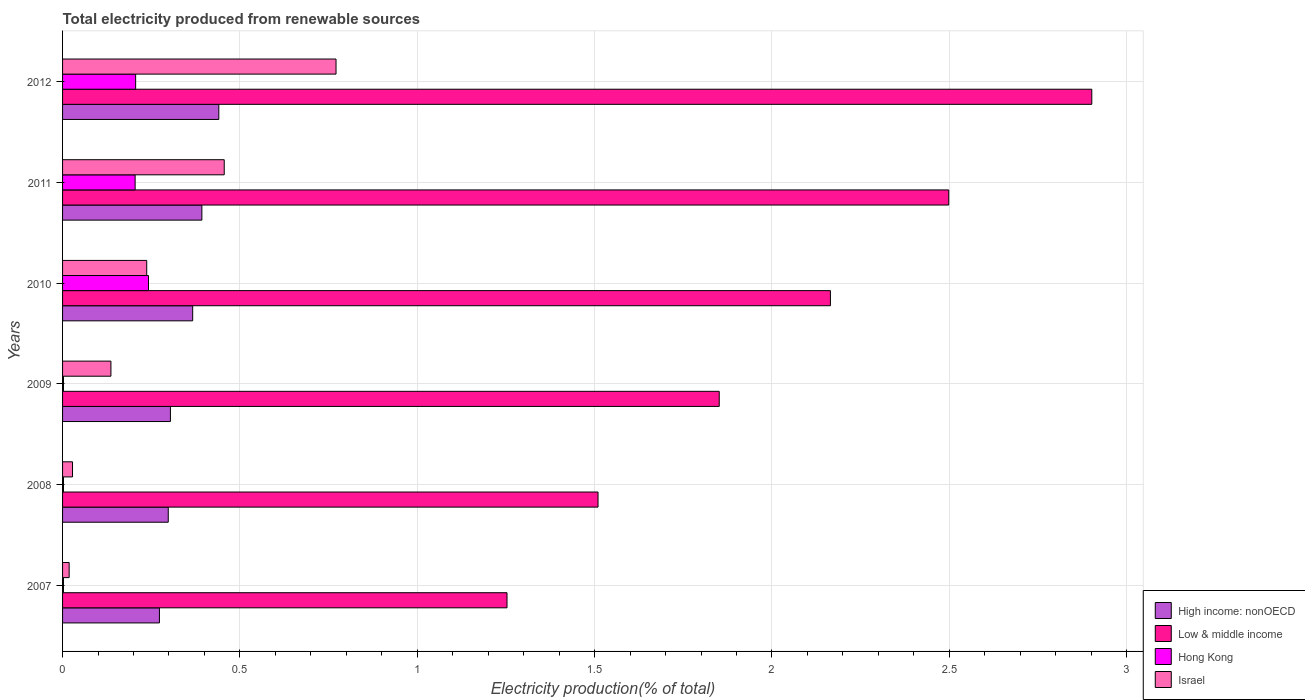Are the number of bars on each tick of the Y-axis equal?
Provide a short and direct response. Yes. What is the label of the 5th group of bars from the top?
Offer a very short reply. 2008. In how many cases, is the number of bars for a given year not equal to the number of legend labels?
Provide a succinct answer. 0. What is the total electricity produced in High income: nonOECD in 2012?
Offer a terse response. 0.44. Across all years, what is the maximum total electricity produced in Hong Kong?
Make the answer very short. 0.24. Across all years, what is the minimum total electricity produced in Low & middle income?
Your response must be concise. 1.25. In which year was the total electricity produced in Israel minimum?
Ensure brevity in your answer.  2007. What is the total total electricity produced in Israel in the graph?
Provide a short and direct response. 1.65. What is the difference between the total electricity produced in Israel in 2008 and that in 2011?
Offer a terse response. -0.43. What is the difference between the total electricity produced in Israel in 2007 and the total electricity produced in Low & middle income in 2012?
Your answer should be very brief. -2.88. What is the average total electricity produced in High income: nonOECD per year?
Offer a very short reply. 0.35. In the year 2007, what is the difference between the total electricity produced in Low & middle income and total electricity produced in Israel?
Give a very brief answer. 1.23. What is the ratio of the total electricity produced in High income: nonOECD in 2010 to that in 2012?
Provide a succinct answer. 0.83. Is the difference between the total electricity produced in Low & middle income in 2008 and 2009 greater than the difference between the total electricity produced in Israel in 2008 and 2009?
Offer a terse response. No. What is the difference between the highest and the second highest total electricity produced in Low & middle income?
Offer a terse response. 0.4. What is the difference between the highest and the lowest total electricity produced in Low & middle income?
Provide a short and direct response. 1.65. In how many years, is the total electricity produced in High income: nonOECD greater than the average total electricity produced in High income: nonOECD taken over all years?
Offer a very short reply. 3. Is the sum of the total electricity produced in Hong Kong in 2009 and 2012 greater than the maximum total electricity produced in Israel across all years?
Provide a short and direct response. No. Is it the case that in every year, the sum of the total electricity produced in Israel and total electricity produced in Hong Kong is greater than the sum of total electricity produced in High income: nonOECD and total electricity produced in Low & middle income?
Give a very brief answer. No. What does the 1st bar from the top in 2012 represents?
Your response must be concise. Israel. What does the 3rd bar from the bottom in 2010 represents?
Keep it short and to the point. Hong Kong. Is it the case that in every year, the sum of the total electricity produced in Hong Kong and total electricity produced in Israel is greater than the total electricity produced in High income: nonOECD?
Provide a short and direct response. No. How many bars are there?
Ensure brevity in your answer.  24. How many years are there in the graph?
Offer a terse response. 6. Are the values on the major ticks of X-axis written in scientific E-notation?
Your response must be concise. No. Does the graph contain any zero values?
Provide a short and direct response. No. Does the graph contain grids?
Keep it short and to the point. Yes. Where does the legend appear in the graph?
Offer a very short reply. Bottom right. How are the legend labels stacked?
Your response must be concise. Vertical. What is the title of the graph?
Offer a very short reply. Total electricity produced from renewable sources. What is the label or title of the X-axis?
Provide a short and direct response. Electricity production(% of total). What is the label or title of the Y-axis?
Make the answer very short. Years. What is the Electricity production(% of total) of High income: nonOECD in 2007?
Keep it short and to the point. 0.27. What is the Electricity production(% of total) in Low & middle income in 2007?
Make the answer very short. 1.25. What is the Electricity production(% of total) of Hong Kong in 2007?
Ensure brevity in your answer.  0. What is the Electricity production(% of total) in Israel in 2007?
Provide a short and direct response. 0.02. What is the Electricity production(% of total) in High income: nonOECD in 2008?
Your answer should be compact. 0.3. What is the Electricity production(% of total) in Low & middle income in 2008?
Your response must be concise. 1.51. What is the Electricity production(% of total) of Hong Kong in 2008?
Make the answer very short. 0. What is the Electricity production(% of total) in Israel in 2008?
Provide a succinct answer. 0.03. What is the Electricity production(% of total) of High income: nonOECD in 2009?
Provide a succinct answer. 0.3. What is the Electricity production(% of total) in Low & middle income in 2009?
Your answer should be very brief. 1.85. What is the Electricity production(% of total) of Hong Kong in 2009?
Your response must be concise. 0. What is the Electricity production(% of total) of Israel in 2009?
Make the answer very short. 0.14. What is the Electricity production(% of total) in High income: nonOECD in 2010?
Your response must be concise. 0.37. What is the Electricity production(% of total) of Low & middle income in 2010?
Give a very brief answer. 2.16. What is the Electricity production(% of total) of Hong Kong in 2010?
Your answer should be very brief. 0.24. What is the Electricity production(% of total) in Israel in 2010?
Offer a terse response. 0.24. What is the Electricity production(% of total) of High income: nonOECD in 2011?
Your answer should be compact. 0.39. What is the Electricity production(% of total) in Low & middle income in 2011?
Your answer should be very brief. 2.5. What is the Electricity production(% of total) in Hong Kong in 2011?
Provide a succinct answer. 0.2. What is the Electricity production(% of total) in Israel in 2011?
Keep it short and to the point. 0.46. What is the Electricity production(% of total) in High income: nonOECD in 2012?
Your answer should be very brief. 0.44. What is the Electricity production(% of total) in Low & middle income in 2012?
Give a very brief answer. 2.9. What is the Electricity production(% of total) of Hong Kong in 2012?
Make the answer very short. 0.21. What is the Electricity production(% of total) of Israel in 2012?
Your answer should be compact. 0.77. Across all years, what is the maximum Electricity production(% of total) in High income: nonOECD?
Your response must be concise. 0.44. Across all years, what is the maximum Electricity production(% of total) in Low & middle income?
Your response must be concise. 2.9. Across all years, what is the maximum Electricity production(% of total) of Hong Kong?
Your response must be concise. 0.24. Across all years, what is the maximum Electricity production(% of total) in Israel?
Provide a short and direct response. 0.77. Across all years, what is the minimum Electricity production(% of total) in High income: nonOECD?
Keep it short and to the point. 0.27. Across all years, what is the minimum Electricity production(% of total) in Low & middle income?
Provide a succinct answer. 1.25. Across all years, what is the minimum Electricity production(% of total) of Hong Kong?
Provide a short and direct response. 0. Across all years, what is the minimum Electricity production(% of total) in Israel?
Give a very brief answer. 0.02. What is the total Electricity production(% of total) in High income: nonOECD in the graph?
Give a very brief answer. 2.08. What is the total Electricity production(% of total) in Low & middle income in the graph?
Offer a terse response. 12.18. What is the total Electricity production(% of total) in Hong Kong in the graph?
Make the answer very short. 0.66. What is the total Electricity production(% of total) in Israel in the graph?
Your response must be concise. 1.65. What is the difference between the Electricity production(% of total) in High income: nonOECD in 2007 and that in 2008?
Make the answer very short. -0.02. What is the difference between the Electricity production(% of total) in Low & middle income in 2007 and that in 2008?
Ensure brevity in your answer.  -0.26. What is the difference between the Electricity production(% of total) in Hong Kong in 2007 and that in 2008?
Your answer should be very brief. -0. What is the difference between the Electricity production(% of total) of Israel in 2007 and that in 2008?
Provide a short and direct response. -0.01. What is the difference between the Electricity production(% of total) of High income: nonOECD in 2007 and that in 2009?
Make the answer very short. -0.03. What is the difference between the Electricity production(% of total) in Low & middle income in 2007 and that in 2009?
Your answer should be very brief. -0.6. What is the difference between the Electricity production(% of total) of Israel in 2007 and that in 2009?
Offer a terse response. -0.12. What is the difference between the Electricity production(% of total) in High income: nonOECD in 2007 and that in 2010?
Your answer should be very brief. -0.09. What is the difference between the Electricity production(% of total) in Low & middle income in 2007 and that in 2010?
Your answer should be very brief. -0.91. What is the difference between the Electricity production(% of total) of Hong Kong in 2007 and that in 2010?
Ensure brevity in your answer.  -0.24. What is the difference between the Electricity production(% of total) of Israel in 2007 and that in 2010?
Your response must be concise. -0.22. What is the difference between the Electricity production(% of total) of High income: nonOECD in 2007 and that in 2011?
Keep it short and to the point. -0.12. What is the difference between the Electricity production(% of total) in Low & middle income in 2007 and that in 2011?
Your response must be concise. -1.25. What is the difference between the Electricity production(% of total) in Hong Kong in 2007 and that in 2011?
Make the answer very short. -0.2. What is the difference between the Electricity production(% of total) in Israel in 2007 and that in 2011?
Make the answer very short. -0.44. What is the difference between the Electricity production(% of total) in High income: nonOECD in 2007 and that in 2012?
Make the answer very short. -0.17. What is the difference between the Electricity production(% of total) of Low & middle income in 2007 and that in 2012?
Ensure brevity in your answer.  -1.65. What is the difference between the Electricity production(% of total) in Hong Kong in 2007 and that in 2012?
Provide a succinct answer. -0.2. What is the difference between the Electricity production(% of total) in Israel in 2007 and that in 2012?
Provide a short and direct response. -0.75. What is the difference between the Electricity production(% of total) in High income: nonOECD in 2008 and that in 2009?
Make the answer very short. -0.01. What is the difference between the Electricity production(% of total) of Low & middle income in 2008 and that in 2009?
Ensure brevity in your answer.  -0.34. What is the difference between the Electricity production(% of total) of Hong Kong in 2008 and that in 2009?
Your response must be concise. 0. What is the difference between the Electricity production(% of total) of Israel in 2008 and that in 2009?
Offer a terse response. -0.11. What is the difference between the Electricity production(% of total) of High income: nonOECD in 2008 and that in 2010?
Make the answer very short. -0.07. What is the difference between the Electricity production(% of total) in Low & middle income in 2008 and that in 2010?
Offer a very short reply. -0.66. What is the difference between the Electricity production(% of total) in Hong Kong in 2008 and that in 2010?
Make the answer very short. -0.24. What is the difference between the Electricity production(% of total) in Israel in 2008 and that in 2010?
Give a very brief answer. -0.21. What is the difference between the Electricity production(% of total) in High income: nonOECD in 2008 and that in 2011?
Offer a very short reply. -0.09. What is the difference between the Electricity production(% of total) in Low & middle income in 2008 and that in 2011?
Provide a short and direct response. -0.99. What is the difference between the Electricity production(% of total) of Hong Kong in 2008 and that in 2011?
Your answer should be very brief. -0.2. What is the difference between the Electricity production(% of total) in Israel in 2008 and that in 2011?
Make the answer very short. -0.43. What is the difference between the Electricity production(% of total) in High income: nonOECD in 2008 and that in 2012?
Ensure brevity in your answer.  -0.14. What is the difference between the Electricity production(% of total) in Low & middle income in 2008 and that in 2012?
Offer a very short reply. -1.39. What is the difference between the Electricity production(% of total) of Hong Kong in 2008 and that in 2012?
Your answer should be very brief. -0.2. What is the difference between the Electricity production(% of total) in Israel in 2008 and that in 2012?
Your answer should be compact. -0.74. What is the difference between the Electricity production(% of total) in High income: nonOECD in 2009 and that in 2010?
Make the answer very short. -0.06. What is the difference between the Electricity production(% of total) of Low & middle income in 2009 and that in 2010?
Your answer should be compact. -0.31. What is the difference between the Electricity production(% of total) in Hong Kong in 2009 and that in 2010?
Offer a very short reply. -0.24. What is the difference between the Electricity production(% of total) of Israel in 2009 and that in 2010?
Ensure brevity in your answer.  -0.1. What is the difference between the Electricity production(% of total) in High income: nonOECD in 2009 and that in 2011?
Ensure brevity in your answer.  -0.09. What is the difference between the Electricity production(% of total) of Low & middle income in 2009 and that in 2011?
Keep it short and to the point. -0.65. What is the difference between the Electricity production(% of total) in Hong Kong in 2009 and that in 2011?
Your response must be concise. -0.2. What is the difference between the Electricity production(% of total) in Israel in 2009 and that in 2011?
Make the answer very short. -0.32. What is the difference between the Electricity production(% of total) of High income: nonOECD in 2009 and that in 2012?
Ensure brevity in your answer.  -0.14. What is the difference between the Electricity production(% of total) of Low & middle income in 2009 and that in 2012?
Your response must be concise. -1.05. What is the difference between the Electricity production(% of total) of Hong Kong in 2009 and that in 2012?
Provide a short and direct response. -0.2. What is the difference between the Electricity production(% of total) of Israel in 2009 and that in 2012?
Offer a very short reply. -0.63. What is the difference between the Electricity production(% of total) in High income: nonOECD in 2010 and that in 2011?
Your response must be concise. -0.03. What is the difference between the Electricity production(% of total) of Low & middle income in 2010 and that in 2011?
Offer a very short reply. -0.33. What is the difference between the Electricity production(% of total) of Hong Kong in 2010 and that in 2011?
Your response must be concise. 0.04. What is the difference between the Electricity production(% of total) in Israel in 2010 and that in 2011?
Keep it short and to the point. -0.22. What is the difference between the Electricity production(% of total) in High income: nonOECD in 2010 and that in 2012?
Offer a terse response. -0.07. What is the difference between the Electricity production(% of total) of Low & middle income in 2010 and that in 2012?
Your answer should be very brief. -0.74. What is the difference between the Electricity production(% of total) of Hong Kong in 2010 and that in 2012?
Offer a very short reply. 0.04. What is the difference between the Electricity production(% of total) in Israel in 2010 and that in 2012?
Your answer should be compact. -0.53. What is the difference between the Electricity production(% of total) of High income: nonOECD in 2011 and that in 2012?
Give a very brief answer. -0.05. What is the difference between the Electricity production(% of total) in Low & middle income in 2011 and that in 2012?
Make the answer very short. -0.4. What is the difference between the Electricity production(% of total) of Hong Kong in 2011 and that in 2012?
Provide a short and direct response. -0. What is the difference between the Electricity production(% of total) of Israel in 2011 and that in 2012?
Offer a terse response. -0.32. What is the difference between the Electricity production(% of total) of High income: nonOECD in 2007 and the Electricity production(% of total) of Low & middle income in 2008?
Keep it short and to the point. -1.24. What is the difference between the Electricity production(% of total) of High income: nonOECD in 2007 and the Electricity production(% of total) of Hong Kong in 2008?
Make the answer very short. 0.27. What is the difference between the Electricity production(% of total) of High income: nonOECD in 2007 and the Electricity production(% of total) of Israel in 2008?
Offer a very short reply. 0.25. What is the difference between the Electricity production(% of total) of Low & middle income in 2007 and the Electricity production(% of total) of Hong Kong in 2008?
Your answer should be very brief. 1.25. What is the difference between the Electricity production(% of total) of Low & middle income in 2007 and the Electricity production(% of total) of Israel in 2008?
Ensure brevity in your answer.  1.23. What is the difference between the Electricity production(% of total) of Hong Kong in 2007 and the Electricity production(% of total) of Israel in 2008?
Your answer should be compact. -0.03. What is the difference between the Electricity production(% of total) of High income: nonOECD in 2007 and the Electricity production(% of total) of Low & middle income in 2009?
Provide a short and direct response. -1.58. What is the difference between the Electricity production(% of total) of High income: nonOECD in 2007 and the Electricity production(% of total) of Hong Kong in 2009?
Keep it short and to the point. 0.27. What is the difference between the Electricity production(% of total) of High income: nonOECD in 2007 and the Electricity production(% of total) of Israel in 2009?
Your answer should be compact. 0.14. What is the difference between the Electricity production(% of total) of Low & middle income in 2007 and the Electricity production(% of total) of Hong Kong in 2009?
Provide a succinct answer. 1.25. What is the difference between the Electricity production(% of total) of Low & middle income in 2007 and the Electricity production(% of total) of Israel in 2009?
Offer a terse response. 1.12. What is the difference between the Electricity production(% of total) of Hong Kong in 2007 and the Electricity production(% of total) of Israel in 2009?
Provide a short and direct response. -0.13. What is the difference between the Electricity production(% of total) in High income: nonOECD in 2007 and the Electricity production(% of total) in Low & middle income in 2010?
Offer a very short reply. -1.89. What is the difference between the Electricity production(% of total) in High income: nonOECD in 2007 and the Electricity production(% of total) in Hong Kong in 2010?
Your response must be concise. 0.03. What is the difference between the Electricity production(% of total) in High income: nonOECD in 2007 and the Electricity production(% of total) in Israel in 2010?
Give a very brief answer. 0.04. What is the difference between the Electricity production(% of total) in Low & middle income in 2007 and the Electricity production(% of total) in Hong Kong in 2010?
Your response must be concise. 1.01. What is the difference between the Electricity production(% of total) of Low & middle income in 2007 and the Electricity production(% of total) of Israel in 2010?
Ensure brevity in your answer.  1.02. What is the difference between the Electricity production(% of total) in Hong Kong in 2007 and the Electricity production(% of total) in Israel in 2010?
Ensure brevity in your answer.  -0.23. What is the difference between the Electricity production(% of total) in High income: nonOECD in 2007 and the Electricity production(% of total) in Low & middle income in 2011?
Provide a succinct answer. -2.23. What is the difference between the Electricity production(% of total) of High income: nonOECD in 2007 and the Electricity production(% of total) of Hong Kong in 2011?
Your answer should be very brief. 0.07. What is the difference between the Electricity production(% of total) in High income: nonOECD in 2007 and the Electricity production(% of total) in Israel in 2011?
Give a very brief answer. -0.18. What is the difference between the Electricity production(% of total) of Low & middle income in 2007 and the Electricity production(% of total) of Hong Kong in 2011?
Your answer should be compact. 1.05. What is the difference between the Electricity production(% of total) in Low & middle income in 2007 and the Electricity production(% of total) in Israel in 2011?
Make the answer very short. 0.8. What is the difference between the Electricity production(% of total) of Hong Kong in 2007 and the Electricity production(% of total) of Israel in 2011?
Ensure brevity in your answer.  -0.45. What is the difference between the Electricity production(% of total) of High income: nonOECD in 2007 and the Electricity production(% of total) of Low & middle income in 2012?
Offer a very short reply. -2.63. What is the difference between the Electricity production(% of total) in High income: nonOECD in 2007 and the Electricity production(% of total) in Hong Kong in 2012?
Offer a terse response. 0.07. What is the difference between the Electricity production(% of total) in High income: nonOECD in 2007 and the Electricity production(% of total) in Israel in 2012?
Your response must be concise. -0.5. What is the difference between the Electricity production(% of total) in Low & middle income in 2007 and the Electricity production(% of total) in Hong Kong in 2012?
Offer a terse response. 1.05. What is the difference between the Electricity production(% of total) in Low & middle income in 2007 and the Electricity production(% of total) in Israel in 2012?
Your answer should be very brief. 0.48. What is the difference between the Electricity production(% of total) in Hong Kong in 2007 and the Electricity production(% of total) in Israel in 2012?
Make the answer very short. -0.77. What is the difference between the Electricity production(% of total) of High income: nonOECD in 2008 and the Electricity production(% of total) of Low & middle income in 2009?
Provide a succinct answer. -1.55. What is the difference between the Electricity production(% of total) in High income: nonOECD in 2008 and the Electricity production(% of total) in Hong Kong in 2009?
Ensure brevity in your answer.  0.3. What is the difference between the Electricity production(% of total) in High income: nonOECD in 2008 and the Electricity production(% of total) in Israel in 2009?
Offer a very short reply. 0.16. What is the difference between the Electricity production(% of total) of Low & middle income in 2008 and the Electricity production(% of total) of Hong Kong in 2009?
Your answer should be compact. 1.51. What is the difference between the Electricity production(% of total) in Low & middle income in 2008 and the Electricity production(% of total) in Israel in 2009?
Your response must be concise. 1.37. What is the difference between the Electricity production(% of total) in Hong Kong in 2008 and the Electricity production(% of total) in Israel in 2009?
Your response must be concise. -0.13. What is the difference between the Electricity production(% of total) in High income: nonOECD in 2008 and the Electricity production(% of total) in Low & middle income in 2010?
Offer a very short reply. -1.87. What is the difference between the Electricity production(% of total) in High income: nonOECD in 2008 and the Electricity production(% of total) in Hong Kong in 2010?
Keep it short and to the point. 0.06. What is the difference between the Electricity production(% of total) of High income: nonOECD in 2008 and the Electricity production(% of total) of Israel in 2010?
Make the answer very short. 0.06. What is the difference between the Electricity production(% of total) in Low & middle income in 2008 and the Electricity production(% of total) in Hong Kong in 2010?
Give a very brief answer. 1.27. What is the difference between the Electricity production(% of total) of Low & middle income in 2008 and the Electricity production(% of total) of Israel in 2010?
Your response must be concise. 1.27. What is the difference between the Electricity production(% of total) of Hong Kong in 2008 and the Electricity production(% of total) of Israel in 2010?
Give a very brief answer. -0.23. What is the difference between the Electricity production(% of total) of High income: nonOECD in 2008 and the Electricity production(% of total) of Low & middle income in 2011?
Provide a short and direct response. -2.2. What is the difference between the Electricity production(% of total) in High income: nonOECD in 2008 and the Electricity production(% of total) in Hong Kong in 2011?
Ensure brevity in your answer.  0.09. What is the difference between the Electricity production(% of total) of High income: nonOECD in 2008 and the Electricity production(% of total) of Israel in 2011?
Offer a terse response. -0.16. What is the difference between the Electricity production(% of total) in Low & middle income in 2008 and the Electricity production(% of total) in Hong Kong in 2011?
Your response must be concise. 1.31. What is the difference between the Electricity production(% of total) in Low & middle income in 2008 and the Electricity production(% of total) in Israel in 2011?
Offer a terse response. 1.05. What is the difference between the Electricity production(% of total) in Hong Kong in 2008 and the Electricity production(% of total) in Israel in 2011?
Provide a short and direct response. -0.45. What is the difference between the Electricity production(% of total) in High income: nonOECD in 2008 and the Electricity production(% of total) in Low & middle income in 2012?
Provide a succinct answer. -2.6. What is the difference between the Electricity production(% of total) in High income: nonOECD in 2008 and the Electricity production(% of total) in Hong Kong in 2012?
Your response must be concise. 0.09. What is the difference between the Electricity production(% of total) of High income: nonOECD in 2008 and the Electricity production(% of total) of Israel in 2012?
Your response must be concise. -0.47. What is the difference between the Electricity production(% of total) in Low & middle income in 2008 and the Electricity production(% of total) in Hong Kong in 2012?
Your answer should be compact. 1.3. What is the difference between the Electricity production(% of total) in Low & middle income in 2008 and the Electricity production(% of total) in Israel in 2012?
Give a very brief answer. 0.74. What is the difference between the Electricity production(% of total) of Hong Kong in 2008 and the Electricity production(% of total) of Israel in 2012?
Your answer should be compact. -0.77. What is the difference between the Electricity production(% of total) of High income: nonOECD in 2009 and the Electricity production(% of total) of Low & middle income in 2010?
Your answer should be compact. -1.86. What is the difference between the Electricity production(% of total) in High income: nonOECD in 2009 and the Electricity production(% of total) in Hong Kong in 2010?
Keep it short and to the point. 0.06. What is the difference between the Electricity production(% of total) of High income: nonOECD in 2009 and the Electricity production(% of total) of Israel in 2010?
Make the answer very short. 0.07. What is the difference between the Electricity production(% of total) in Low & middle income in 2009 and the Electricity production(% of total) in Hong Kong in 2010?
Provide a short and direct response. 1.61. What is the difference between the Electricity production(% of total) in Low & middle income in 2009 and the Electricity production(% of total) in Israel in 2010?
Offer a very short reply. 1.61. What is the difference between the Electricity production(% of total) in Hong Kong in 2009 and the Electricity production(% of total) in Israel in 2010?
Provide a succinct answer. -0.23. What is the difference between the Electricity production(% of total) in High income: nonOECD in 2009 and the Electricity production(% of total) in Low & middle income in 2011?
Keep it short and to the point. -2.19. What is the difference between the Electricity production(% of total) of High income: nonOECD in 2009 and the Electricity production(% of total) of Hong Kong in 2011?
Offer a very short reply. 0.1. What is the difference between the Electricity production(% of total) in High income: nonOECD in 2009 and the Electricity production(% of total) in Israel in 2011?
Provide a succinct answer. -0.15. What is the difference between the Electricity production(% of total) of Low & middle income in 2009 and the Electricity production(% of total) of Hong Kong in 2011?
Your answer should be compact. 1.65. What is the difference between the Electricity production(% of total) in Low & middle income in 2009 and the Electricity production(% of total) in Israel in 2011?
Offer a terse response. 1.4. What is the difference between the Electricity production(% of total) in Hong Kong in 2009 and the Electricity production(% of total) in Israel in 2011?
Offer a terse response. -0.45. What is the difference between the Electricity production(% of total) in High income: nonOECD in 2009 and the Electricity production(% of total) in Low & middle income in 2012?
Offer a very short reply. -2.6. What is the difference between the Electricity production(% of total) of High income: nonOECD in 2009 and the Electricity production(% of total) of Hong Kong in 2012?
Offer a terse response. 0.1. What is the difference between the Electricity production(% of total) in High income: nonOECD in 2009 and the Electricity production(% of total) in Israel in 2012?
Your answer should be compact. -0.47. What is the difference between the Electricity production(% of total) of Low & middle income in 2009 and the Electricity production(% of total) of Hong Kong in 2012?
Offer a terse response. 1.65. What is the difference between the Electricity production(% of total) in Low & middle income in 2009 and the Electricity production(% of total) in Israel in 2012?
Offer a terse response. 1.08. What is the difference between the Electricity production(% of total) in Hong Kong in 2009 and the Electricity production(% of total) in Israel in 2012?
Offer a very short reply. -0.77. What is the difference between the Electricity production(% of total) in High income: nonOECD in 2010 and the Electricity production(% of total) in Low & middle income in 2011?
Offer a very short reply. -2.13. What is the difference between the Electricity production(% of total) in High income: nonOECD in 2010 and the Electricity production(% of total) in Hong Kong in 2011?
Offer a very short reply. 0.16. What is the difference between the Electricity production(% of total) in High income: nonOECD in 2010 and the Electricity production(% of total) in Israel in 2011?
Ensure brevity in your answer.  -0.09. What is the difference between the Electricity production(% of total) of Low & middle income in 2010 and the Electricity production(% of total) of Hong Kong in 2011?
Your answer should be compact. 1.96. What is the difference between the Electricity production(% of total) in Low & middle income in 2010 and the Electricity production(% of total) in Israel in 2011?
Your answer should be compact. 1.71. What is the difference between the Electricity production(% of total) in Hong Kong in 2010 and the Electricity production(% of total) in Israel in 2011?
Ensure brevity in your answer.  -0.21. What is the difference between the Electricity production(% of total) in High income: nonOECD in 2010 and the Electricity production(% of total) in Low & middle income in 2012?
Offer a terse response. -2.53. What is the difference between the Electricity production(% of total) of High income: nonOECD in 2010 and the Electricity production(% of total) of Hong Kong in 2012?
Offer a terse response. 0.16. What is the difference between the Electricity production(% of total) of High income: nonOECD in 2010 and the Electricity production(% of total) of Israel in 2012?
Ensure brevity in your answer.  -0.4. What is the difference between the Electricity production(% of total) of Low & middle income in 2010 and the Electricity production(% of total) of Hong Kong in 2012?
Offer a very short reply. 1.96. What is the difference between the Electricity production(% of total) in Low & middle income in 2010 and the Electricity production(% of total) in Israel in 2012?
Your answer should be compact. 1.39. What is the difference between the Electricity production(% of total) of Hong Kong in 2010 and the Electricity production(% of total) of Israel in 2012?
Ensure brevity in your answer.  -0.53. What is the difference between the Electricity production(% of total) of High income: nonOECD in 2011 and the Electricity production(% of total) of Low & middle income in 2012?
Offer a very short reply. -2.51. What is the difference between the Electricity production(% of total) in High income: nonOECD in 2011 and the Electricity production(% of total) in Hong Kong in 2012?
Your answer should be compact. 0.19. What is the difference between the Electricity production(% of total) in High income: nonOECD in 2011 and the Electricity production(% of total) in Israel in 2012?
Provide a succinct answer. -0.38. What is the difference between the Electricity production(% of total) in Low & middle income in 2011 and the Electricity production(% of total) in Hong Kong in 2012?
Your answer should be compact. 2.29. What is the difference between the Electricity production(% of total) in Low & middle income in 2011 and the Electricity production(% of total) in Israel in 2012?
Make the answer very short. 1.73. What is the difference between the Electricity production(% of total) of Hong Kong in 2011 and the Electricity production(% of total) of Israel in 2012?
Offer a terse response. -0.57. What is the average Electricity production(% of total) in High income: nonOECD per year?
Provide a short and direct response. 0.35. What is the average Electricity production(% of total) of Low & middle income per year?
Keep it short and to the point. 2.03. What is the average Electricity production(% of total) in Hong Kong per year?
Your response must be concise. 0.11. What is the average Electricity production(% of total) of Israel per year?
Provide a short and direct response. 0.27. In the year 2007, what is the difference between the Electricity production(% of total) in High income: nonOECD and Electricity production(% of total) in Low & middle income?
Your response must be concise. -0.98. In the year 2007, what is the difference between the Electricity production(% of total) of High income: nonOECD and Electricity production(% of total) of Hong Kong?
Provide a short and direct response. 0.27. In the year 2007, what is the difference between the Electricity production(% of total) of High income: nonOECD and Electricity production(% of total) of Israel?
Keep it short and to the point. 0.25. In the year 2007, what is the difference between the Electricity production(% of total) of Low & middle income and Electricity production(% of total) of Hong Kong?
Make the answer very short. 1.25. In the year 2007, what is the difference between the Electricity production(% of total) of Low & middle income and Electricity production(% of total) of Israel?
Your answer should be very brief. 1.23. In the year 2007, what is the difference between the Electricity production(% of total) of Hong Kong and Electricity production(% of total) of Israel?
Offer a very short reply. -0.02. In the year 2008, what is the difference between the Electricity production(% of total) of High income: nonOECD and Electricity production(% of total) of Low & middle income?
Provide a short and direct response. -1.21. In the year 2008, what is the difference between the Electricity production(% of total) of High income: nonOECD and Electricity production(% of total) of Hong Kong?
Make the answer very short. 0.3. In the year 2008, what is the difference between the Electricity production(% of total) in High income: nonOECD and Electricity production(% of total) in Israel?
Your answer should be very brief. 0.27. In the year 2008, what is the difference between the Electricity production(% of total) in Low & middle income and Electricity production(% of total) in Hong Kong?
Provide a short and direct response. 1.51. In the year 2008, what is the difference between the Electricity production(% of total) in Low & middle income and Electricity production(% of total) in Israel?
Provide a short and direct response. 1.48. In the year 2008, what is the difference between the Electricity production(% of total) in Hong Kong and Electricity production(% of total) in Israel?
Provide a succinct answer. -0.03. In the year 2009, what is the difference between the Electricity production(% of total) in High income: nonOECD and Electricity production(% of total) in Low & middle income?
Give a very brief answer. -1.55. In the year 2009, what is the difference between the Electricity production(% of total) of High income: nonOECD and Electricity production(% of total) of Hong Kong?
Keep it short and to the point. 0.3. In the year 2009, what is the difference between the Electricity production(% of total) in High income: nonOECD and Electricity production(% of total) in Israel?
Provide a succinct answer. 0.17. In the year 2009, what is the difference between the Electricity production(% of total) of Low & middle income and Electricity production(% of total) of Hong Kong?
Provide a succinct answer. 1.85. In the year 2009, what is the difference between the Electricity production(% of total) in Low & middle income and Electricity production(% of total) in Israel?
Offer a terse response. 1.72. In the year 2009, what is the difference between the Electricity production(% of total) of Hong Kong and Electricity production(% of total) of Israel?
Ensure brevity in your answer.  -0.13. In the year 2010, what is the difference between the Electricity production(% of total) in High income: nonOECD and Electricity production(% of total) in Low & middle income?
Ensure brevity in your answer.  -1.8. In the year 2010, what is the difference between the Electricity production(% of total) of High income: nonOECD and Electricity production(% of total) of Hong Kong?
Ensure brevity in your answer.  0.12. In the year 2010, what is the difference between the Electricity production(% of total) in High income: nonOECD and Electricity production(% of total) in Israel?
Keep it short and to the point. 0.13. In the year 2010, what is the difference between the Electricity production(% of total) in Low & middle income and Electricity production(% of total) in Hong Kong?
Your answer should be very brief. 1.92. In the year 2010, what is the difference between the Electricity production(% of total) in Low & middle income and Electricity production(% of total) in Israel?
Provide a short and direct response. 1.93. In the year 2010, what is the difference between the Electricity production(% of total) in Hong Kong and Electricity production(% of total) in Israel?
Your answer should be very brief. 0.01. In the year 2011, what is the difference between the Electricity production(% of total) of High income: nonOECD and Electricity production(% of total) of Low & middle income?
Offer a terse response. -2.11. In the year 2011, what is the difference between the Electricity production(% of total) in High income: nonOECD and Electricity production(% of total) in Hong Kong?
Ensure brevity in your answer.  0.19. In the year 2011, what is the difference between the Electricity production(% of total) of High income: nonOECD and Electricity production(% of total) of Israel?
Offer a terse response. -0.06. In the year 2011, what is the difference between the Electricity production(% of total) of Low & middle income and Electricity production(% of total) of Hong Kong?
Offer a very short reply. 2.29. In the year 2011, what is the difference between the Electricity production(% of total) in Low & middle income and Electricity production(% of total) in Israel?
Ensure brevity in your answer.  2.04. In the year 2011, what is the difference between the Electricity production(% of total) in Hong Kong and Electricity production(% of total) in Israel?
Your response must be concise. -0.25. In the year 2012, what is the difference between the Electricity production(% of total) of High income: nonOECD and Electricity production(% of total) of Low & middle income?
Your answer should be compact. -2.46. In the year 2012, what is the difference between the Electricity production(% of total) in High income: nonOECD and Electricity production(% of total) in Hong Kong?
Provide a succinct answer. 0.23. In the year 2012, what is the difference between the Electricity production(% of total) of High income: nonOECD and Electricity production(% of total) of Israel?
Ensure brevity in your answer.  -0.33. In the year 2012, what is the difference between the Electricity production(% of total) of Low & middle income and Electricity production(% of total) of Hong Kong?
Your response must be concise. 2.7. In the year 2012, what is the difference between the Electricity production(% of total) in Low & middle income and Electricity production(% of total) in Israel?
Give a very brief answer. 2.13. In the year 2012, what is the difference between the Electricity production(% of total) in Hong Kong and Electricity production(% of total) in Israel?
Ensure brevity in your answer.  -0.56. What is the ratio of the Electricity production(% of total) in High income: nonOECD in 2007 to that in 2008?
Your response must be concise. 0.92. What is the ratio of the Electricity production(% of total) in Low & middle income in 2007 to that in 2008?
Offer a terse response. 0.83. What is the ratio of the Electricity production(% of total) of Hong Kong in 2007 to that in 2008?
Keep it short and to the point. 0.98. What is the ratio of the Electricity production(% of total) of Israel in 2007 to that in 2008?
Offer a very short reply. 0.66. What is the ratio of the Electricity production(% of total) in High income: nonOECD in 2007 to that in 2009?
Make the answer very short. 0.9. What is the ratio of the Electricity production(% of total) of Low & middle income in 2007 to that in 2009?
Give a very brief answer. 0.68. What is the ratio of the Electricity production(% of total) in Israel in 2007 to that in 2009?
Make the answer very short. 0.14. What is the ratio of the Electricity production(% of total) of High income: nonOECD in 2007 to that in 2010?
Your response must be concise. 0.74. What is the ratio of the Electricity production(% of total) of Low & middle income in 2007 to that in 2010?
Ensure brevity in your answer.  0.58. What is the ratio of the Electricity production(% of total) of Hong Kong in 2007 to that in 2010?
Give a very brief answer. 0.01. What is the ratio of the Electricity production(% of total) in Israel in 2007 to that in 2010?
Give a very brief answer. 0.08. What is the ratio of the Electricity production(% of total) in High income: nonOECD in 2007 to that in 2011?
Your response must be concise. 0.7. What is the ratio of the Electricity production(% of total) in Low & middle income in 2007 to that in 2011?
Your answer should be compact. 0.5. What is the ratio of the Electricity production(% of total) of Hong Kong in 2007 to that in 2011?
Keep it short and to the point. 0.01. What is the ratio of the Electricity production(% of total) in Israel in 2007 to that in 2011?
Give a very brief answer. 0.04. What is the ratio of the Electricity production(% of total) of High income: nonOECD in 2007 to that in 2012?
Provide a short and direct response. 0.62. What is the ratio of the Electricity production(% of total) in Low & middle income in 2007 to that in 2012?
Your answer should be very brief. 0.43. What is the ratio of the Electricity production(% of total) of Hong Kong in 2007 to that in 2012?
Your answer should be very brief. 0.01. What is the ratio of the Electricity production(% of total) of Israel in 2007 to that in 2012?
Keep it short and to the point. 0.02. What is the ratio of the Electricity production(% of total) in High income: nonOECD in 2008 to that in 2009?
Provide a succinct answer. 0.98. What is the ratio of the Electricity production(% of total) of Low & middle income in 2008 to that in 2009?
Provide a succinct answer. 0.82. What is the ratio of the Electricity production(% of total) in Hong Kong in 2008 to that in 2009?
Your answer should be very brief. 1.02. What is the ratio of the Electricity production(% of total) in Israel in 2008 to that in 2009?
Your answer should be very brief. 0.21. What is the ratio of the Electricity production(% of total) of High income: nonOECD in 2008 to that in 2010?
Give a very brief answer. 0.81. What is the ratio of the Electricity production(% of total) in Low & middle income in 2008 to that in 2010?
Your response must be concise. 0.7. What is the ratio of the Electricity production(% of total) in Hong Kong in 2008 to that in 2010?
Make the answer very short. 0.01. What is the ratio of the Electricity production(% of total) in Israel in 2008 to that in 2010?
Your answer should be very brief. 0.12. What is the ratio of the Electricity production(% of total) in High income: nonOECD in 2008 to that in 2011?
Provide a short and direct response. 0.76. What is the ratio of the Electricity production(% of total) in Low & middle income in 2008 to that in 2011?
Keep it short and to the point. 0.6. What is the ratio of the Electricity production(% of total) in Hong Kong in 2008 to that in 2011?
Provide a short and direct response. 0.01. What is the ratio of the Electricity production(% of total) of Israel in 2008 to that in 2011?
Offer a very short reply. 0.06. What is the ratio of the Electricity production(% of total) of High income: nonOECD in 2008 to that in 2012?
Ensure brevity in your answer.  0.68. What is the ratio of the Electricity production(% of total) in Low & middle income in 2008 to that in 2012?
Offer a terse response. 0.52. What is the ratio of the Electricity production(% of total) in Hong Kong in 2008 to that in 2012?
Offer a terse response. 0.01. What is the ratio of the Electricity production(% of total) of Israel in 2008 to that in 2012?
Your response must be concise. 0.04. What is the ratio of the Electricity production(% of total) of High income: nonOECD in 2009 to that in 2010?
Keep it short and to the point. 0.83. What is the ratio of the Electricity production(% of total) of Low & middle income in 2009 to that in 2010?
Your answer should be compact. 0.86. What is the ratio of the Electricity production(% of total) of Hong Kong in 2009 to that in 2010?
Your answer should be very brief. 0.01. What is the ratio of the Electricity production(% of total) in Israel in 2009 to that in 2010?
Keep it short and to the point. 0.57. What is the ratio of the Electricity production(% of total) of High income: nonOECD in 2009 to that in 2011?
Keep it short and to the point. 0.77. What is the ratio of the Electricity production(% of total) of Low & middle income in 2009 to that in 2011?
Your response must be concise. 0.74. What is the ratio of the Electricity production(% of total) of Hong Kong in 2009 to that in 2011?
Give a very brief answer. 0.01. What is the ratio of the Electricity production(% of total) of Israel in 2009 to that in 2011?
Your response must be concise. 0.3. What is the ratio of the Electricity production(% of total) of High income: nonOECD in 2009 to that in 2012?
Your answer should be very brief. 0.69. What is the ratio of the Electricity production(% of total) of Low & middle income in 2009 to that in 2012?
Ensure brevity in your answer.  0.64. What is the ratio of the Electricity production(% of total) in Hong Kong in 2009 to that in 2012?
Offer a very short reply. 0.01. What is the ratio of the Electricity production(% of total) in Israel in 2009 to that in 2012?
Provide a short and direct response. 0.18. What is the ratio of the Electricity production(% of total) of High income: nonOECD in 2010 to that in 2011?
Provide a succinct answer. 0.93. What is the ratio of the Electricity production(% of total) of Low & middle income in 2010 to that in 2011?
Your answer should be compact. 0.87. What is the ratio of the Electricity production(% of total) of Hong Kong in 2010 to that in 2011?
Make the answer very short. 1.18. What is the ratio of the Electricity production(% of total) of Israel in 2010 to that in 2011?
Provide a short and direct response. 0.52. What is the ratio of the Electricity production(% of total) of High income: nonOECD in 2010 to that in 2012?
Ensure brevity in your answer.  0.83. What is the ratio of the Electricity production(% of total) of Low & middle income in 2010 to that in 2012?
Make the answer very short. 0.75. What is the ratio of the Electricity production(% of total) in Hong Kong in 2010 to that in 2012?
Your answer should be very brief. 1.18. What is the ratio of the Electricity production(% of total) of Israel in 2010 to that in 2012?
Your answer should be very brief. 0.31. What is the ratio of the Electricity production(% of total) of High income: nonOECD in 2011 to that in 2012?
Your answer should be very brief. 0.89. What is the ratio of the Electricity production(% of total) of Low & middle income in 2011 to that in 2012?
Provide a short and direct response. 0.86. What is the ratio of the Electricity production(% of total) in Israel in 2011 to that in 2012?
Your response must be concise. 0.59. What is the difference between the highest and the second highest Electricity production(% of total) in High income: nonOECD?
Offer a terse response. 0.05. What is the difference between the highest and the second highest Electricity production(% of total) of Low & middle income?
Offer a terse response. 0.4. What is the difference between the highest and the second highest Electricity production(% of total) in Hong Kong?
Offer a very short reply. 0.04. What is the difference between the highest and the second highest Electricity production(% of total) in Israel?
Your response must be concise. 0.32. What is the difference between the highest and the lowest Electricity production(% of total) of High income: nonOECD?
Give a very brief answer. 0.17. What is the difference between the highest and the lowest Electricity production(% of total) in Low & middle income?
Your answer should be compact. 1.65. What is the difference between the highest and the lowest Electricity production(% of total) in Hong Kong?
Ensure brevity in your answer.  0.24. What is the difference between the highest and the lowest Electricity production(% of total) of Israel?
Keep it short and to the point. 0.75. 